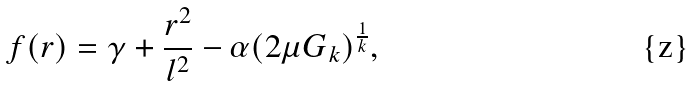Convert formula to latex. <formula><loc_0><loc_0><loc_500><loc_500>f ( r ) = \gamma + \frac { r ^ { 2 } } { l ^ { 2 } } - \alpha ( 2 \mu G _ { k } ) ^ { \frac { 1 } { k } } ,</formula> 